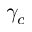<formula> <loc_0><loc_0><loc_500><loc_500>\gamma _ { c }</formula> 